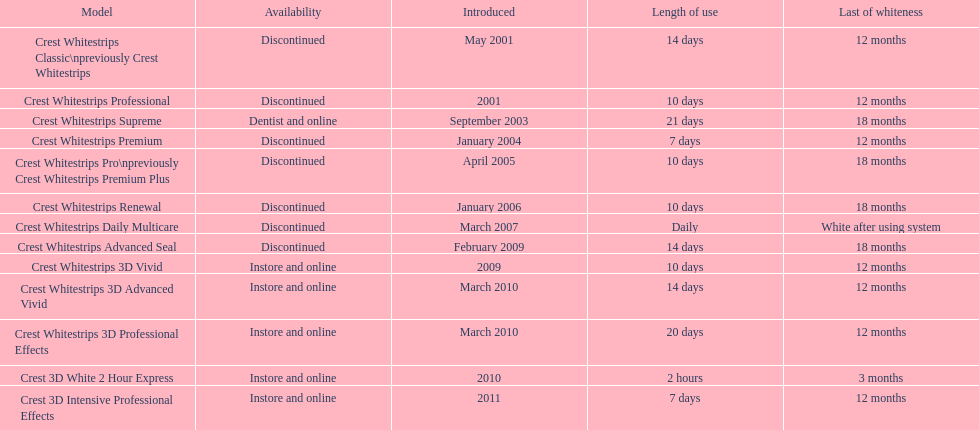Can you give me this table as a dict? {'header': ['Model', 'Availability', 'Introduced', 'Length of use', 'Last of whiteness'], 'rows': [['Crest Whitestrips Classic\\npreviously Crest Whitestrips', 'Discontinued', 'May 2001', '14 days', '12 months'], ['Crest Whitestrips Professional', 'Discontinued', '2001', '10 days', '12 months'], ['Crest Whitestrips Supreme', 'Dentist and online', 'September 2003', '21 days', '18 months'], ['Crest Whitestrips Premium', 'Discontinued', 'January 2004', '7 days', '12 months'], ['Crest Whitestrips Pro\\npreviously Crest Whitestrips Premium Plus', 'Discontinued', 'April 2005', '10 days', '18 months'], ['Crest Whitestrips Renewal', 'Discontinued', 'January 2006', '10 days', '18 months'], ['Crest Whitestrips Daily Multicare', 'Discontinued', 'March 2007', 'Daily', 'White after using system'], ['Crest Whitestrips Advanced Seal', 'Discontinued', 'February 2009', '14 days', '18 months'], ['Crest Whitestrips 3D Vivid', 'Instore and online', '2009', '10 days', '12 months'], ['Crest Whitestrips 3D Advanced Vivid', 'Instore and online', 'March 2010', '14 days', '12 months'], ['Crest Whitestrips 3D Professional Effects', 'Instore and online', 'March 2010', '20 days', '12 months'], ['Crest 3D White 2 Hour Express', 'Instore and online', '2010', '2 hours', '3 months'], ['Crest 3D Intensive Professional Effects', 'Instore and online', '2011', '7 days', '12 months']]} Which product was launched alongside crest whitestrips 3d advanced vivid in the same month? Crest Whitestrips 3D Professional Effects. 